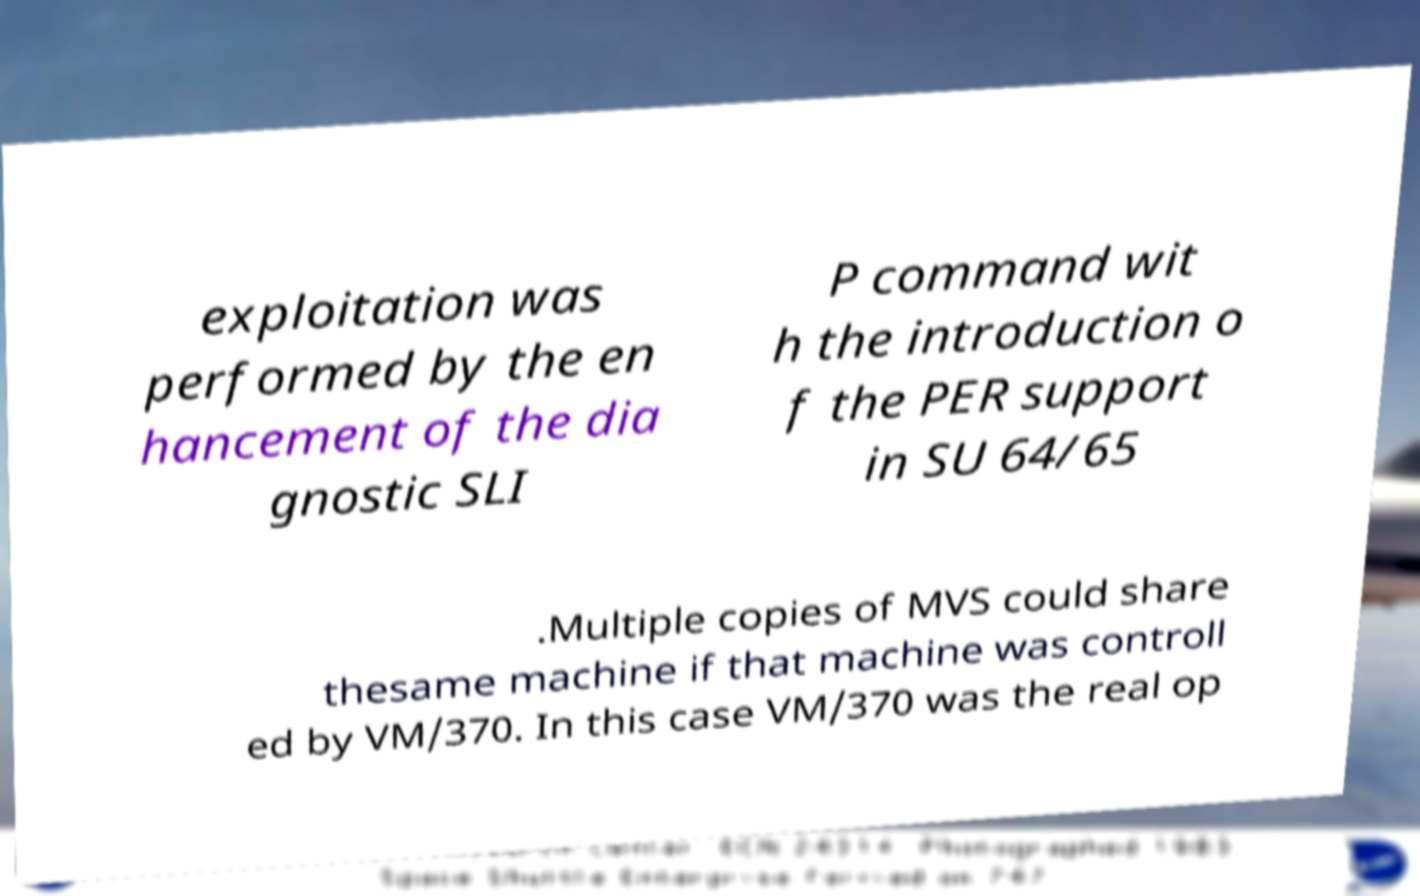Please read and relay the text visible in this image. What does it say? exploitation was performed by the en hancement of the dia gnostic SLI P command wit h the introduction o f the PER support in SU 64/65 .Multiple copies of MVS could share thesame machine if that machine was controll ed by VM/370. In this case VM/370 was the real op 